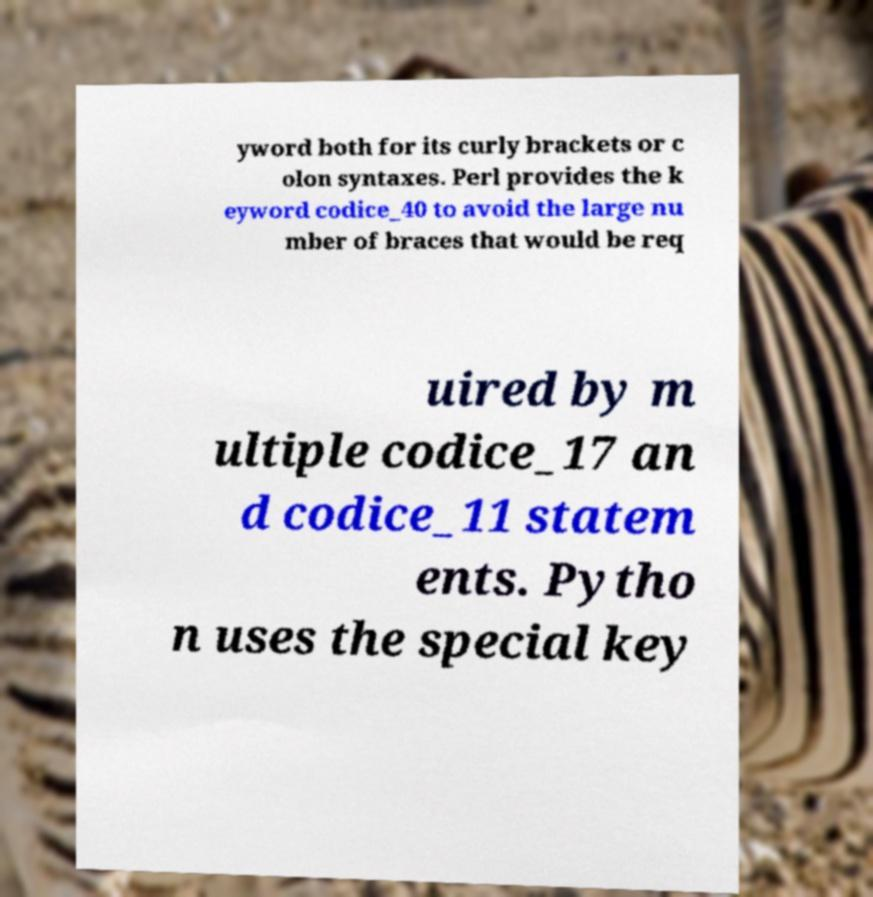For documentation purposes, I need the text within this image transcribed. Could you provide that? yword both for its curly brackets or c olon syntaxes. Perl provides the k eyword codice_40 to avoid the large nu mber of braces that would be req uired by m ultiple codice_17 an d codice_11 statem ents. Pytho n uses the special key 